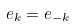Convert formula to latex. <formula><loc_0><loc_0><loc_500><loc_500>e _ { k } = e _ { - k }</formula> 